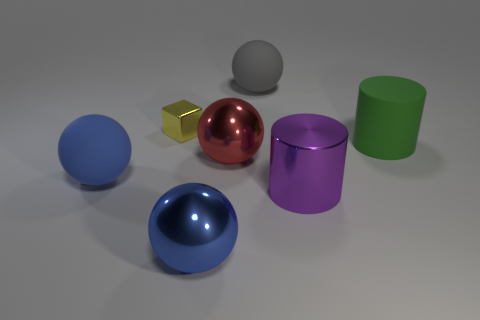Subtract all big blue matte spheres. How many spheres are left? 3 Subtract all purple cylinders. How many cylinders are left? 1 Subtract all cylinders. How many objects are left? 5 Add 3 big green things. How many objects exist? 10 Subtract 1 cylinders. How many cylinders are left? 1 Subtract all cyan cubes. Subtract all cyan spheres. How many cubes are left? 1 Subtract all gray spheres. How many purple cylinders are left? 1 Subtract all tiny green metal cylinders. Subtract all gray things. How many objects are left? 6 Add 6 big rubber cylinders. How many big rubber cylinders are left? 7 Add 5 tiny yellow cubes. How many tiny yellow cubes exist? 6 